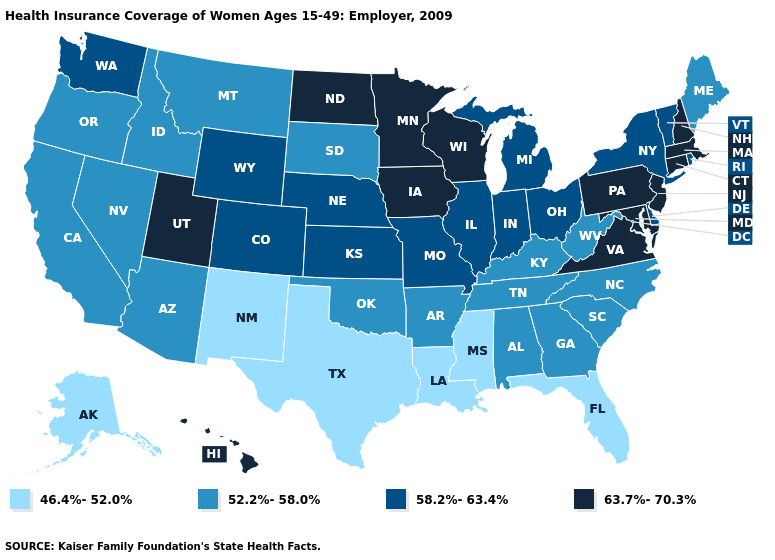How many symbols are there in the legend?
Give a very brief answer. 4. Among the states that border Michigan , does Wisconsin have the lowest value?
Write a very short answer. No. Among the states that border North Dakota , does Minnesota have the highest value?
Answer briefly. Yes. Which states have the lowest value in the West?
Concise answer only. Alaska, New Mexico. What is the lowest value in the South?
Keep it brief. 46.4%-52.0%. Does Kansas have the highest value in the USA?
Write a very short answer. No. Does North Carolina have a lower value than Vermont?
Keep it brief. Yes. Name the states that have a value in the range 58.2%-63.4%?
Give a very brief answer. Colorado, Delaware, Illinois, Indiana, Kansas, Michigan, Missouri, Nebraska, New York, Ohio, Rhode Island, Vermont, Washington, Wyoming. Among the states that border South Carolina , which have the lowest value?
Quick response, please. Georgia, North Carolina. Does South Dakota have the same value as West Virginia?
Quick response, please. Yes. What is the lowest value in the USA?
Be succinct. 46.4%-52.0%. Which states hav the highest value in the West?
Quick response, please. Hawaii, Utah. What is the highest value in the USA?
Concise answer only. 63.7%-70.3%. Name the states that have a value in the range 63.7%-70.3%?
Answer briefly. Connecticut, Hawaii, Iowa, Maryland, Massachusetts, Minnesota, New Hampshire, New Jersey, North Dakota, Pennsylvania, Utah, Virginia, Wisconsin. Name the states that have a value in the range 52.2%-58.0%?
Quick response, please. Alabama, Arizona, Arkansas, California, Georgia, Idaho, Kentucky, Maine, Montana, Nevada, North Carolina, Oklahoma, Oregon, South Carolina, South Dakota, Tennessee, West Virginia. 